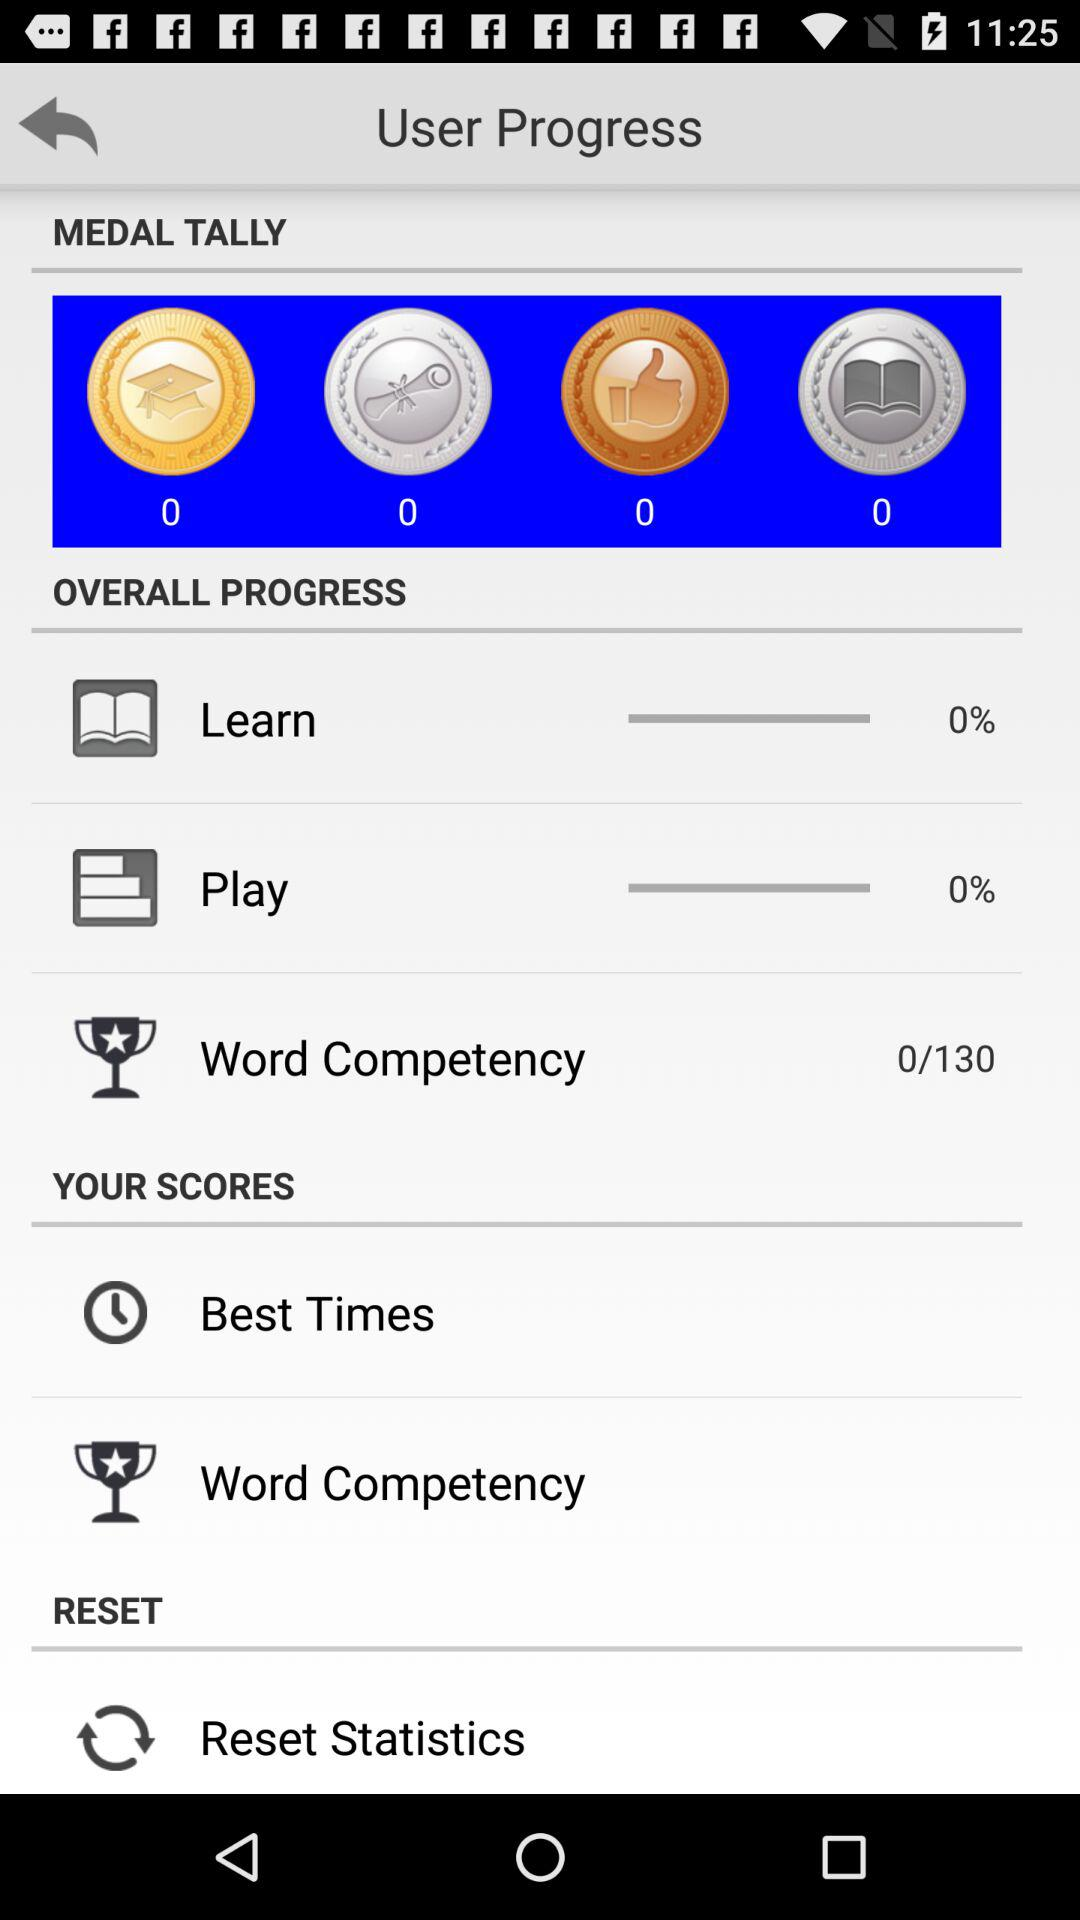What is the learning progress? The learning progress is 0%. 